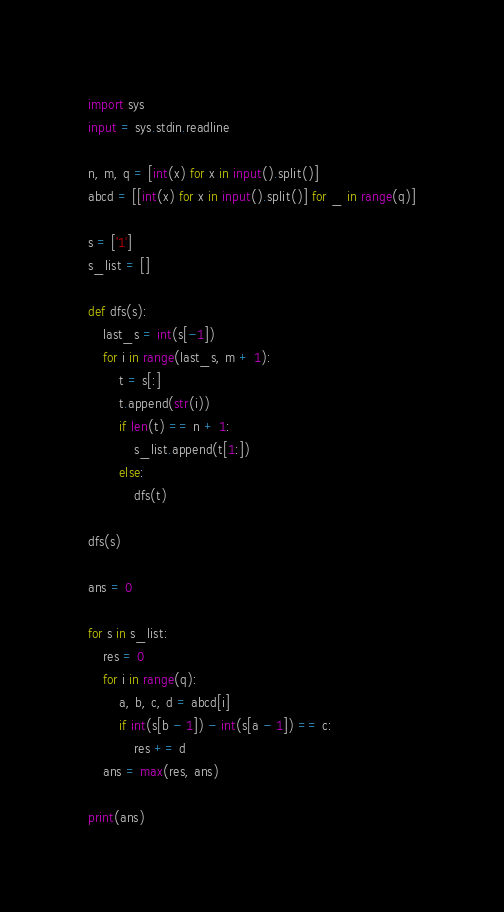<code> <loc_0><loc_0><loc_500><loc_500><_Python_>import sys
input = sys.stdin.readline

n, m, q = [int(x) for x in input().split()]
abcd = [[int(x) for x in input().split()] for _ in range(q)]

s = ['1']
s_list = []

def dfs(s):
    last_s = int(s[-1])
    for i in range(last_s, m + 1):
        t = s[:]
        t.append(str(i))
        if len(t) == n + 1:
            s_list.append(t[1:])
        else:
            dfs(t)

dfs(s)

ans = 0

for s in s_list:
    res = 0
    for i in range(q):
        a, b, c, d = abcd[i]
        if int(s[b - 1]) - int(s[a - 1]) == c:
            res += d
    ans = max(res, ans)

print(ans)



</code> 